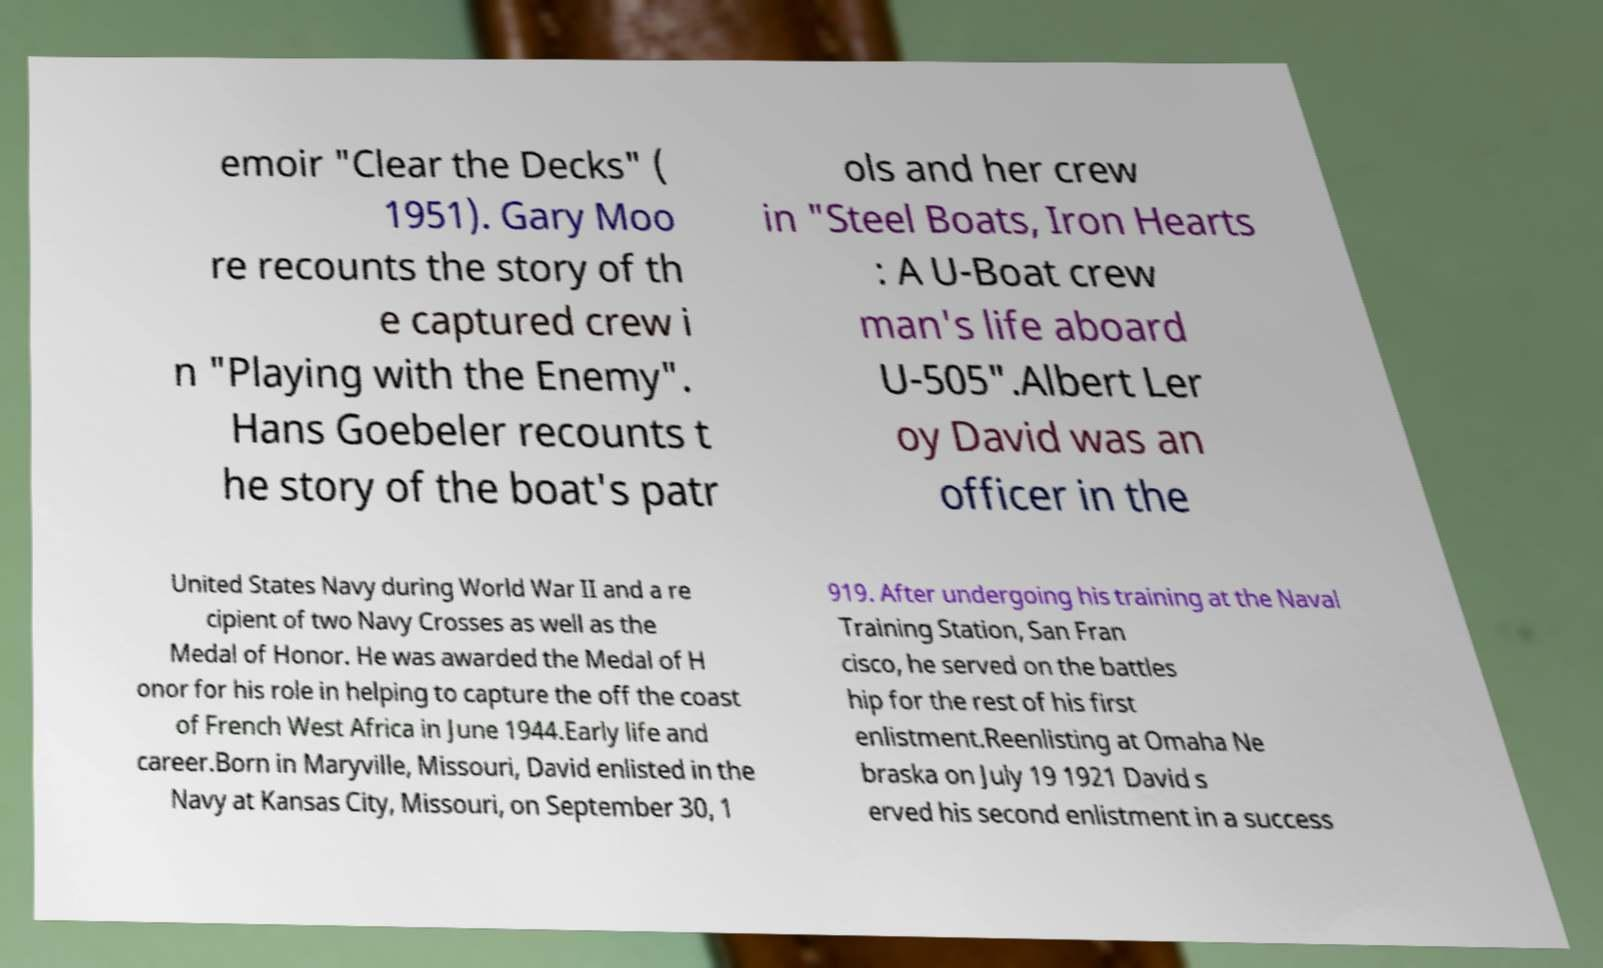What messages or text are displayed in this image? I need them in a readable, typed format. emoir "Clear the Decks" ( 1951). Gary Moo re recounts the story of th e captured crew i n "Playing with the Enemy". Hans Goebeler recounts t he story of the boat's patr ols and her crew in "Steel Boats, Iron Hearts : A U-Boat crew man's life aboard U-505".Albert Ler oy David was an officer in the United States Navy during World War II and a re cipient of two Navy Crosses as well as the Medal of Honor. He was awarded the Medal of H onor for his role in helping to capture the off the coast of French West Africa in June 1944.Early life and career.Born in Maryville, Missouri, David enlisted in the Navy at Kansas City, Missouri, on September 30, 1 919. After undergoing his training at the Naval Training Station, San Fran cisco, he served on the battles hip for the rest of his first enlistment.Reenlisting at Omaha Ne braska on July 19 1921 David s erved his second enlistment in a success 